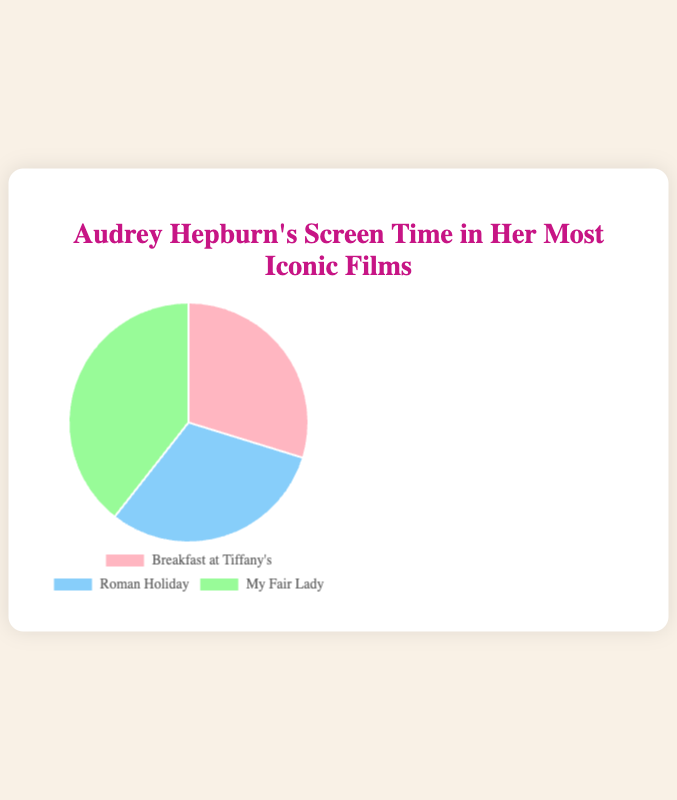Which film has the longest screen time? The pie chart shows the screen times of Audrey Hepburn's three most iconic films. By comparing the slice sizes, the film with the largest slice (i.e., the most screen time) is identified.
Answer: My Fair Lady What's the total combined screen time for all three films? The pie chart provides screen times for three films. Add the screen times from each segment: 114 (Breakfast at Tiffany's) + 118 (Roman Holiday) + 151 (My Fair Lady).
Answer: 383 minutes How much shorter is Audrey Hepburn’s screen time in "Breakfast at Tiffany's" compared to "My Fair Lady"? Look at the screen times assigned to each film. Subtract the screen time for "Breakfast at Tiffany's" (114 minutes) from that for "My Fair Lady" (151 minutes).
Answer: 37 minutes Which film has the smallest screen time slice, and what color is it? By looking at the pie chart, identify the smallest segment and note the corresponding color. The smallest segment represents "Breakfast at Tiffany's", which is colored pink.
Answer: Breakfast at Tiffany's, pink Is the screen time of "Roman Holiday" closer to "Breakfast at Tiffany's" or "My Fair Lady"? Compare the screen times. "Roman Holiday" has 118 minutes, "Breakfast at Tiffany's" has 114 minutes, and "My Fair Lady" has 151 minutes. Calculate the differences: 118 - 114 = 4 minutes and 151 - 118 = 33 minutes.
Answer: Breakfast at Tiffany's What is the average screen time of the three films? Add the screen times of all three films and divide by the number of films. (114 + 118 + 151) / 3.
Answer: 127.67 minutes How many more minutes does "My Fair Lady" have compared to the average screen time? First, calculate the average screen time (127.67 minutes). Then, subtract the average from "My Fair Lady" screen time (151 - 127.67).
Answer: 23.33 minutes Which two films combined have more screen time than "My Fair Lady"? Compare the combined screen times of each pair of films with "My Fair Lady"'s screen time. "Breakfast at Tiffany's" and "Roman Holiday" combined equals 232 minutes (114 + 118), which is greater than "My Fair Lady" (151 minutes).
Answer: Breakfast at Tiffany's and Roman Holiday Is "Roman Holiday" screen time closer to the 115-minute mark or farther? Compare the screen time of "Roman Holiday" (118 minutes) to 115 minutes by finding the absolute difference: 118 - 115 = 3 minutes.
Answer: Closer What percentage of total screen time is "Breakfast at Tiffany's"? Divide the screen time of "Breakfast at Tiffany's" by the total screen time and multiply by 100%. (114 / 383) * 100%.
Answer: 29.76% 